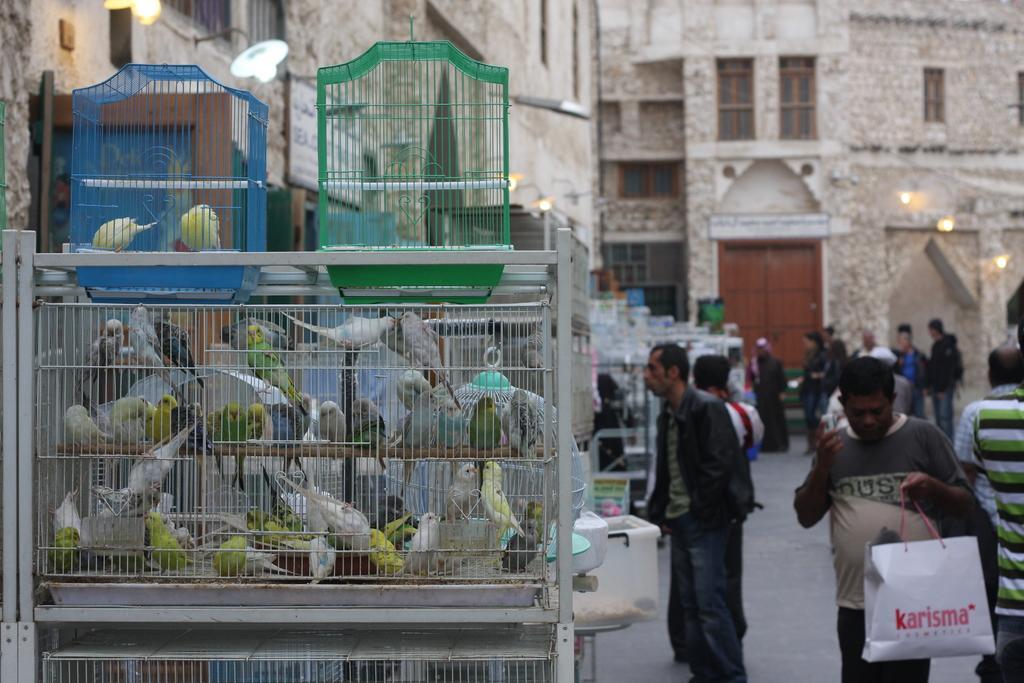Describe this image in one or two sentences. In this picture we can see birds in cages, group of people on the ground, lights and some objects and in the background we can see buildings with windows. 